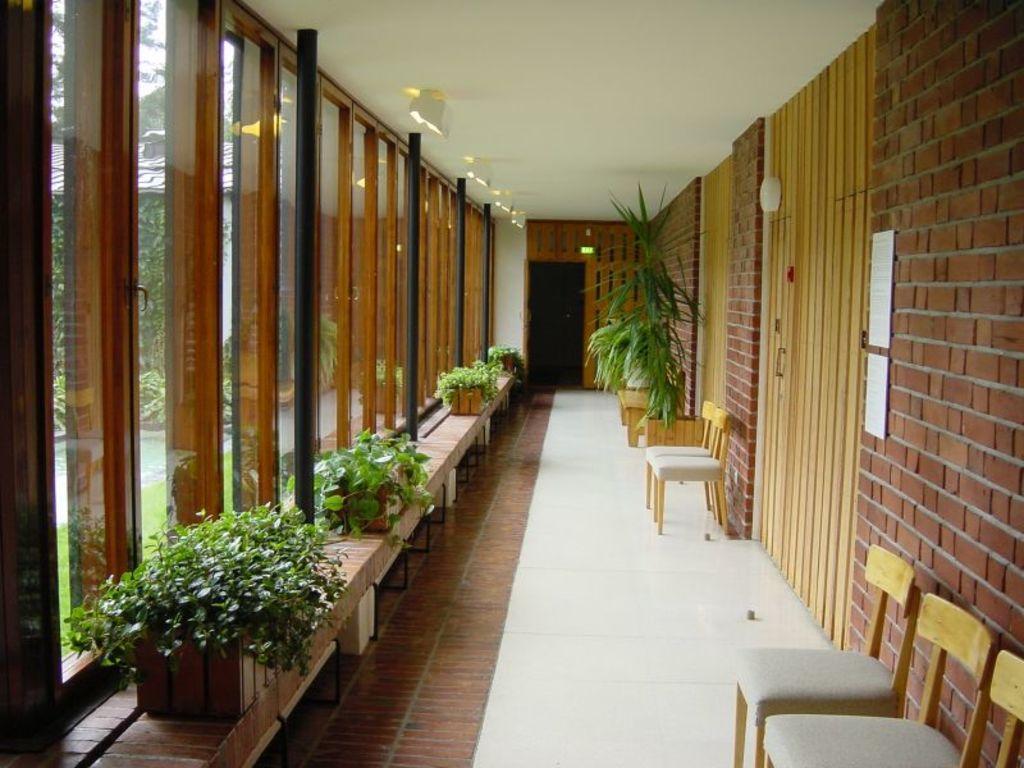Could you give a brief overview of what you see in this image? In this image on the right side there is a wall and chairs, flower pot, plants and on the left side there are glass windows, flower pots and plants. At the bottom there is floor, and in the background there is door, at the top there is ceiling and lights and on the left side through the windows i can see some plants, grass and pavement. 